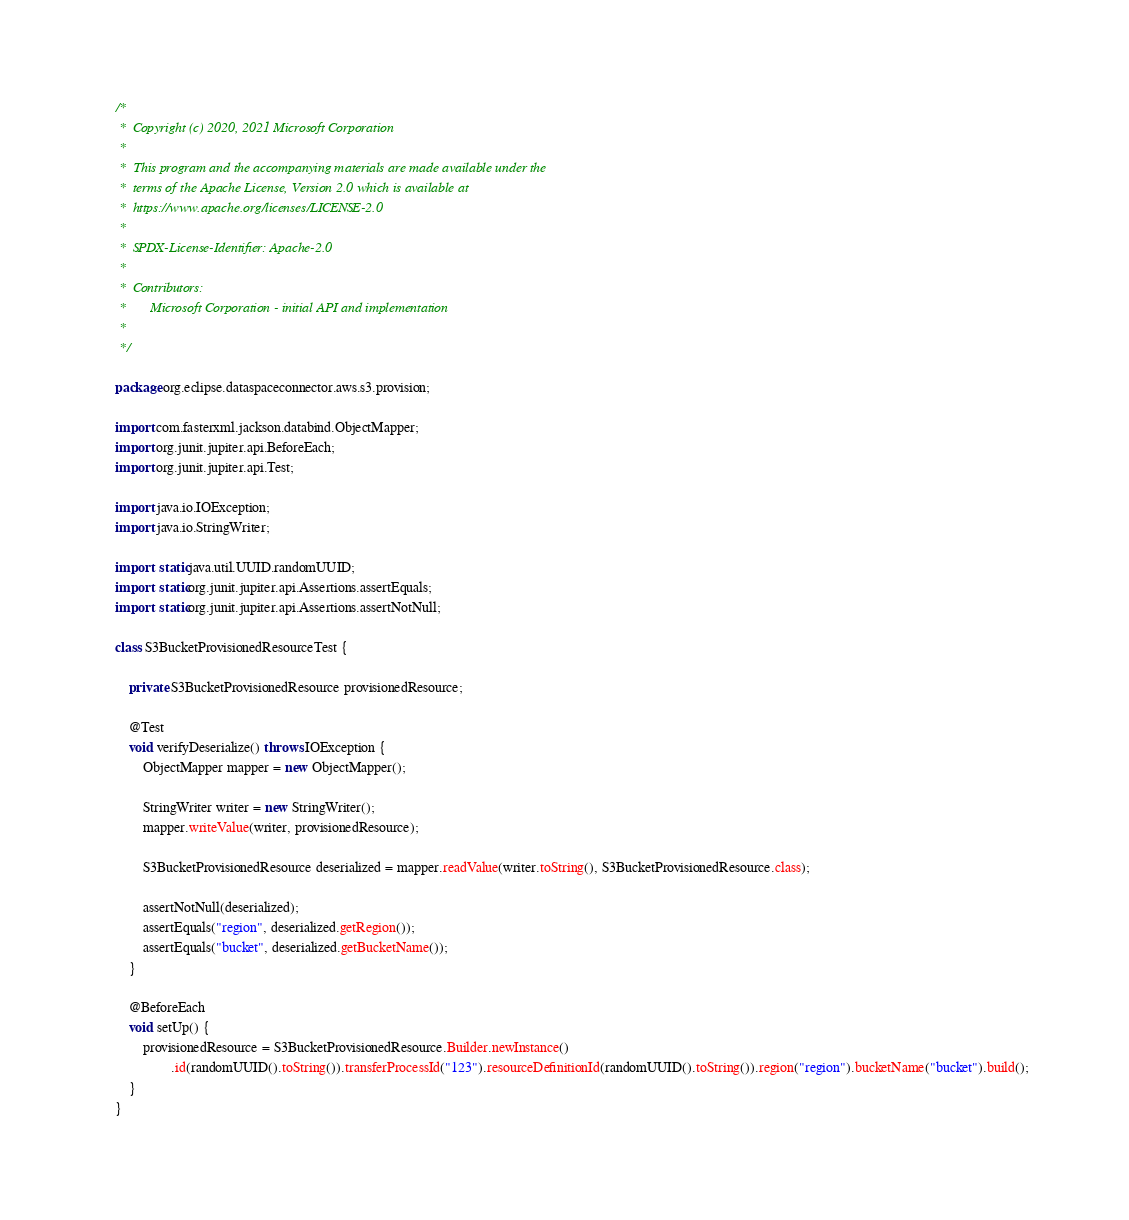<code> <loc_0><loc_0><loc_500><loc_500><_Java_>/*
 *  Copyright (c) 2020, 2021 Microsoft Corporation
 *
 *  This program and the accompanying materials are made available under the
 *  terms of the Apache License, Version 2.0 which is available at
 *  https://www.apache.org/licenses/LICENSE-2.0
 *
 *  SPDX-License-Identifier: Apache-2.0
 *
 *  Contributors:
 *       Microsoft Corporation - initial API and implementation
 *
 */

package org.eclipse.dataspaceconnector.aws.s3.provision;

import com.fasterxml.jackson.databind.ObjectMapper;
import org.junit.jupiter.api.BeforeEach;
import org.junit.jupiter.api.Test;

import java.io.IOException;
import java.io.StringWriter;

import static java.util.UUID.randomUUID;
import static org.junit.jupiter.api.Assertions.assertEquals;
import static org.junit.jupiter.api.Assertions.assertNotNull;

class S3BucketProvisionedResourceTest {

    private S3BucketProvisionedResource provisionedResource;

    @Test
    void verifyDeserialize() throws IOException {
        ObjectMapper mapper = new ObjectMapper();

        StringWriter writer = new StringWriter();
        mapper.writeValue(writer, provisionedResource);

        S3BucketProvisionedResource deserialized = mapper.readValue(writer.toString(), S3BucketProvisionedResource.class);

        assertNotNull(deserialized);
        assertEquals("region", deserialized.getRegion());
        assertEquals("bucket", deserialized.getBucketName());
    }

    @BeforeEach
    void setUp() {
        provisionedResource = S3BucketProvisionedResource.Builder.newInstance()
                .id(randomUUID().toString()).transferProcessId("123").resourceDefinitionId(randomUUID().toString()).region("region").bucketName("bucket").build();
    }
}
</code> 